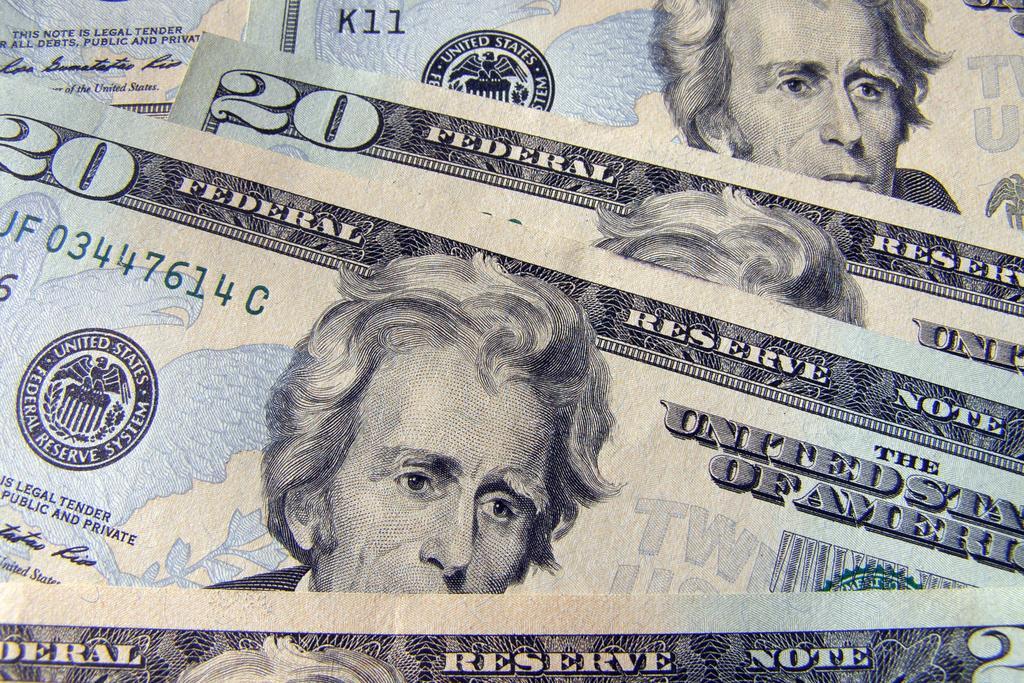Please provide a concise description of this image. In the image there are few dollar notes visible. 